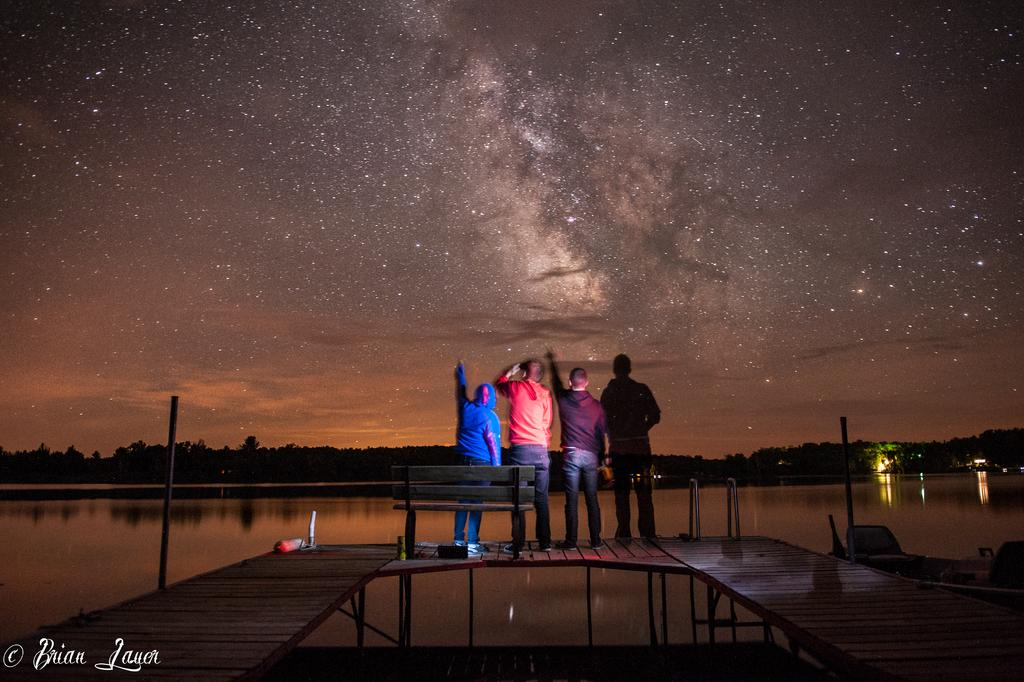How many people are in the image? There are four people in the image. Where are the people located in the image? The people are standing on a bridge. What can be seen in the background of the image? There is water, trees, and the sky visible in the background of the image. What type of sponge can be seen floating in the water in the image? There is no sponge visible in the image; only water, trees, and the sky are present in the background. 